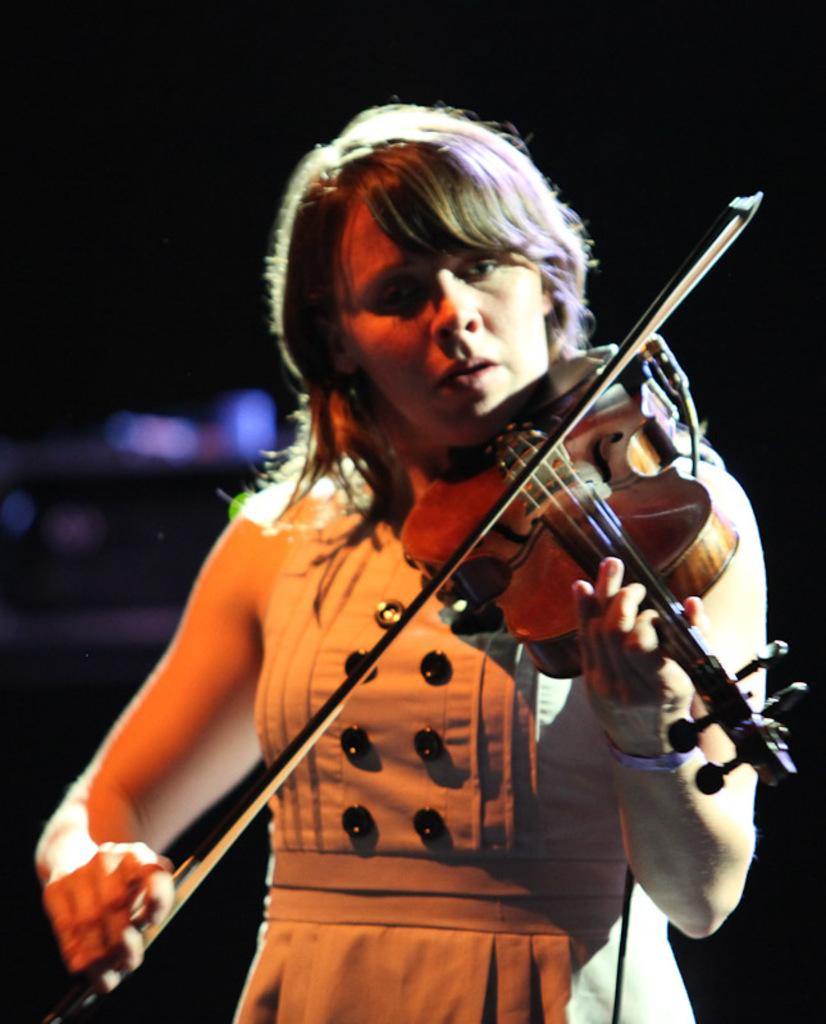What is the main subject of the image? The main subject of the image is a woman. What is the woman doing in the image? The woman is playing a violin in the image. What type of alarm is the woman using to accompany her violin playing in the image? There is no alarm present in the image; the woman is playing a violin without any accompaniment. How many legs does the woman have in the image? The woman has two legs, but this information is not relevant to the image's content and is not mentioned in the provided facts. 